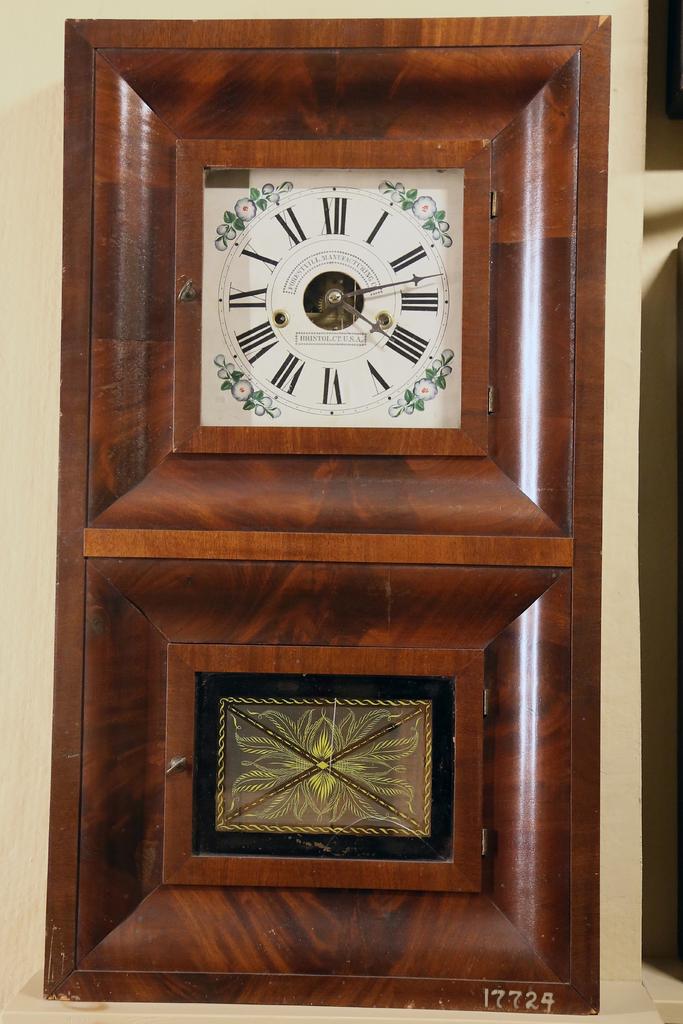How is the numbers written on the clock?
Offer a very short reply. Roman numerals. 